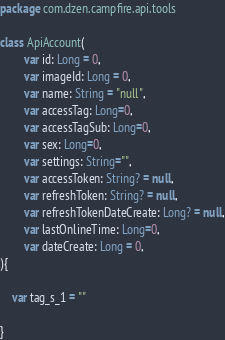<code> <loc_0><loc_0><loc_500><loc_500><_Kotlin_>package com.dzen.campfire.api.tools

class ApiAccount(
        var id: Long = 0,
        var imageId: Long = 0,
        var name: String = "null",
        var accessTag: Long=0,
        var accessTagSub: Long=0,
        var sex: Long=0,
        var settings: String="",
        var accessToken: String? = null,
        var refreshToken: String? = null,
        var refreshTokenDateCreate: Long? = null,
        var lastOnlineTime: Long=0,
        var dateCreate: Long = 0,
){

    var tag_s_1 = ""

}</code> 